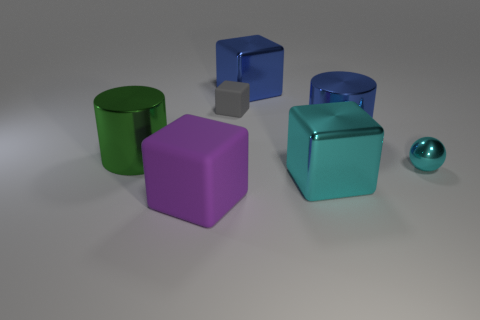There is a matte thing that is behind the rubber object in front of the large metallic cylinder that is right of the large matte cube; what shape is it?
Keep it short and to the point. Cube. There is a matte thing that is in front of the large green shiny object; is its shape the same as the tiny thing that is on the right side of the tiny gray rubber block?
Offer a terse response. No. What number of cylinders are either large green shiny objects or large cyan shiny things?
Offer a terse response. 1. Is the material of the small gray thing the same as the large blue block?
Offer a terse response. No. How many other things are the same color as the shiny ball?
Ensure brevity in your answer.  1. There is a big shiny thing in front of the big green metallic cylinder; what shape is it?
Give a very brief answer. Cube. What number of things are big green cylinders or spheres?
Provide a short and direct response. 2. There is a cyan ball; does it have the same size as the matte object that is in front of the cyan sphere?
Your answer should be compact. No. What number of other things are made of the same material as the blue cube?
Ensure brevity in your answer.  4. What number of things are either large metallic cubes that are in front of the green metal cylinder or matte things that are left of the tiny rubber thing?
Offer a terse response. 2. 